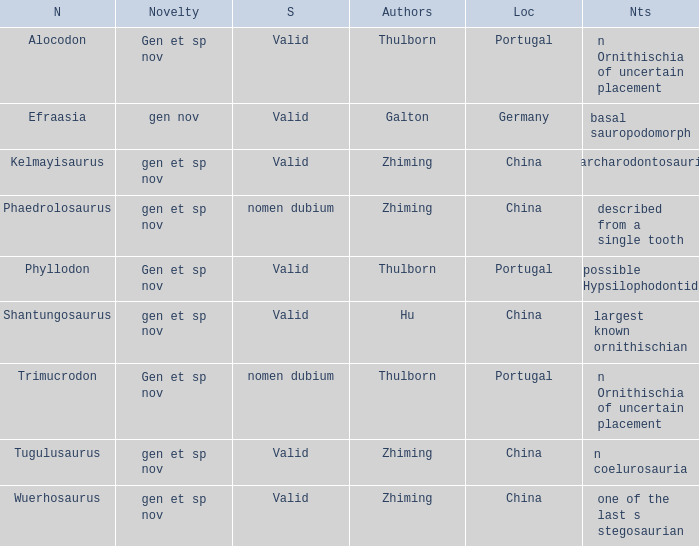What is the Name of the dinosaur that was discovered in the Location, China, and whose Notes are, "described from a single tooth"? Phaedrolosaurus. 